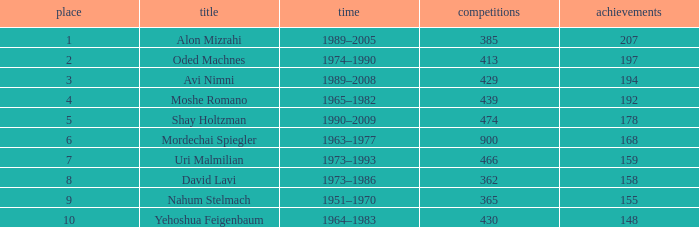What is the Rank of the player with 158 Goals in more than 362 Matches? 0.0. 